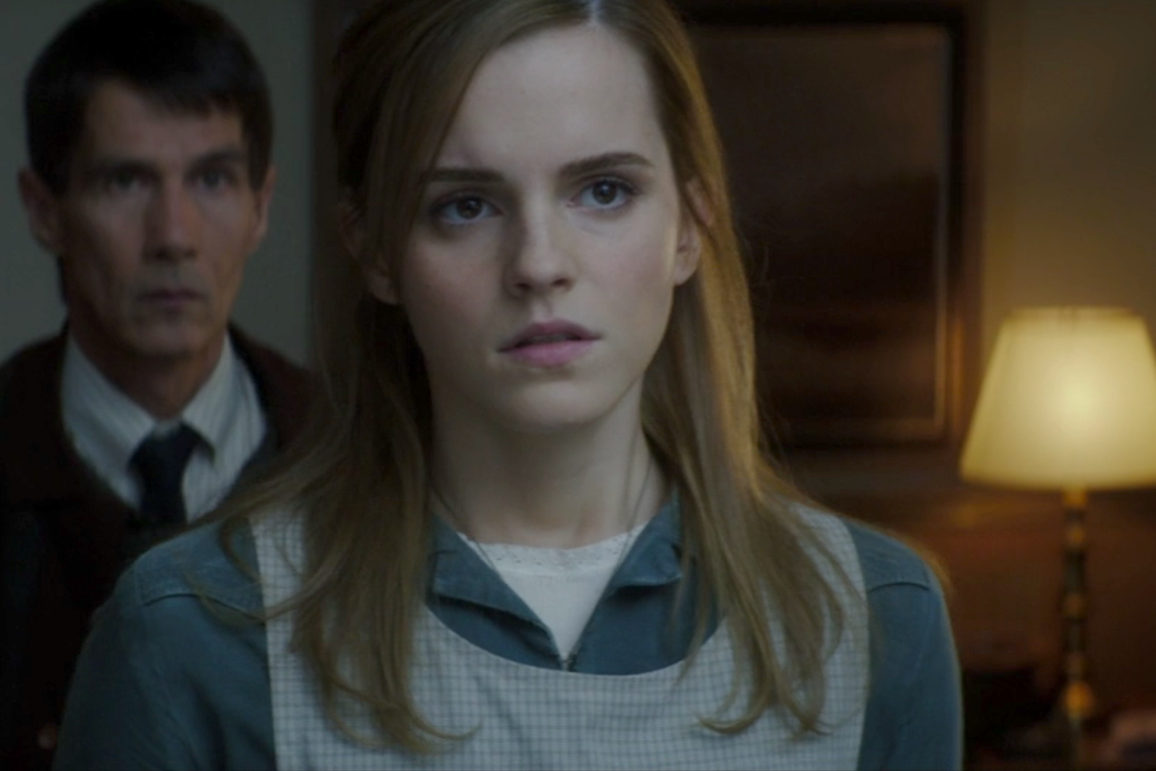Picture this as a scene from a sci-fi series. What futuristic elements could you include in this description? In this sci-fi series scene, the woman in the foreground is a skilled hacker, having just accessed classified data that unmasks a conspiracy threatening humanity. Her somber expression reflects the gravity of what she has uncovered. The man in the background is an android, created to protect her but conflicted as his programming battles between loyalty and the directives from his creators. The room is subtly filled with futuristic elements - holographic interfaces displaying complex data streams float around them, and the lamp casts an ethereal glow, powered by advanced, unseen technology. The shadows and lighting amplify the suspense of the discovery, setting the stage for a tense standoff. 